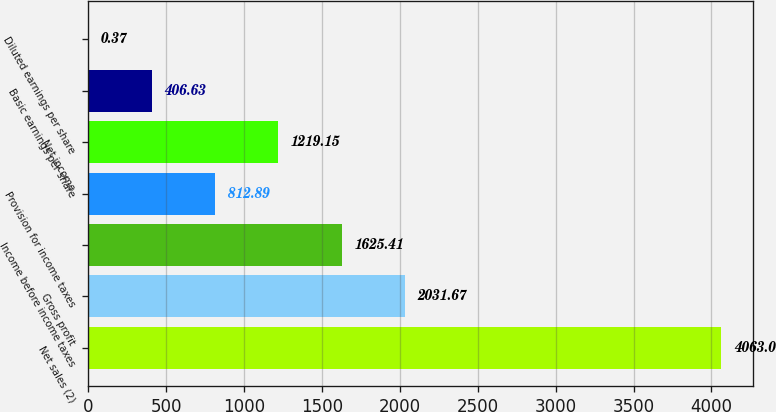Convert chart. <chart><loc_0><loc_0><loc_500><loc_500><bar_chart><fcel>Net sales (2)<fcel>Gross profit<fcel>Income before income taxes<fcel>Provision for income taxes<fcel>Net income<fcel>Basic earnings per share<fcel>Diluted earnings per share<nl><fcel>4063<fcel>2031.67<fcel>1625.41<fcel>812.89<fcel>1219.15<fcel>406.63<fcel>0.37<nl></chart> 